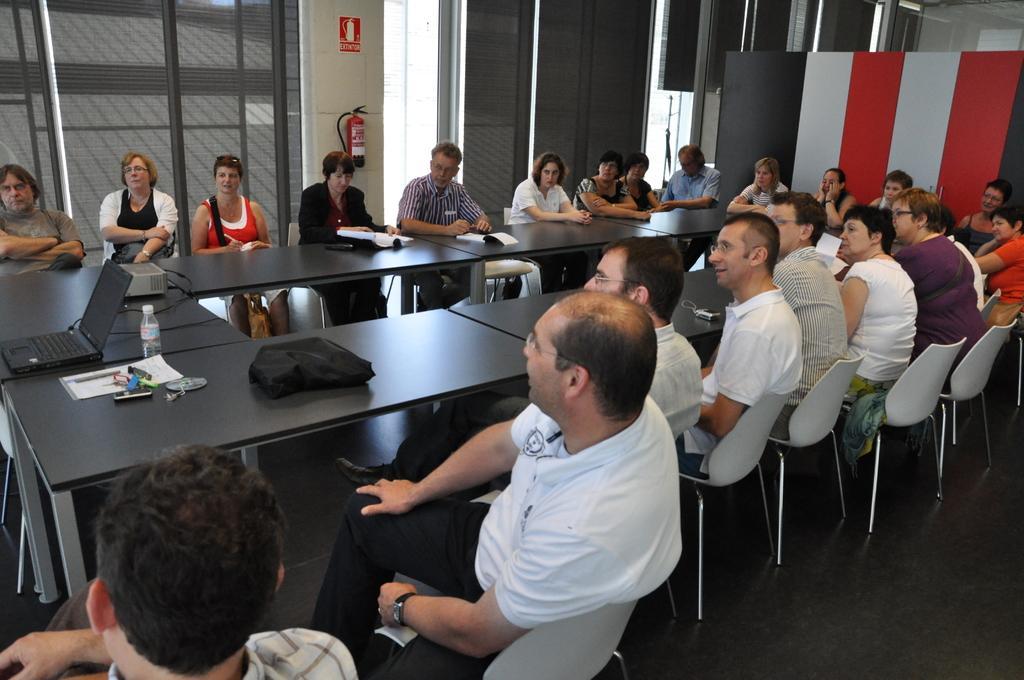How would you summarize this image in a sentence or two? There are table. On the table there are books, laptop, bottles, bag and some other items. Many people are sitting on chairs. In the back there is a wall. On the wall there is a name board and fire extinguisher. 